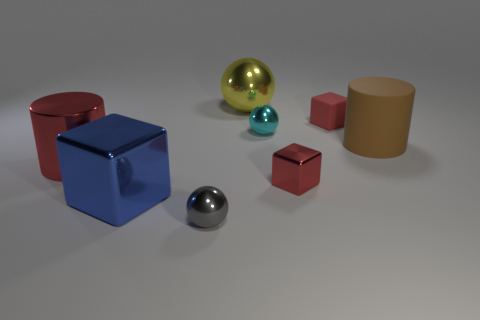Is the size of the red shiny object that is right of the gray metallic ball the same as the cyan metal sphere?
Provide a succinct answer. Yes. How many brown objects are the same shape as the large red metallic thing?
Provide a succinct answer. 1. The cylinder that is made of the same material as the yellow ball is what size?
Your answer should be very brief. Large. Is the number of large things that are behind the tiny red shiny cube the same as the number of large brown cylinders?
Provide a short and direct response. No. Does the tiny matte object have the same color as the big metal cylinder?
Make the answer very short. Yes. There is a large thing that is behind the red matte block; does it have the same shape as the large thing to the right of the big ball?
Offer a very short reply. No. What material is the other object that is the same shape as the brown rubber thing?
Provide a succinct answer. Metal. There is a shiny object that is both in front of the large brown matte thing and right of the big yellow metal object; what is its color?
Keep it short and to the point. Red. Are there any big yellow balls that are in front of the metal block left of the tiny thing that is in front of the blue metallic thing?
Offer a terse response. No. How many things are either purple things or tiny red blocks?
Ensure brevity in your answer.  2. 